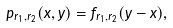<formula> <loc_0><loc_0><loc_500><loc_500>\ p _ { r _ { 1 } , r _ { 2 } } ( x , y ) = \hat { f } _ { r _ { 1 } , r _ { 2 } } ( y - x ) ,</formula> 